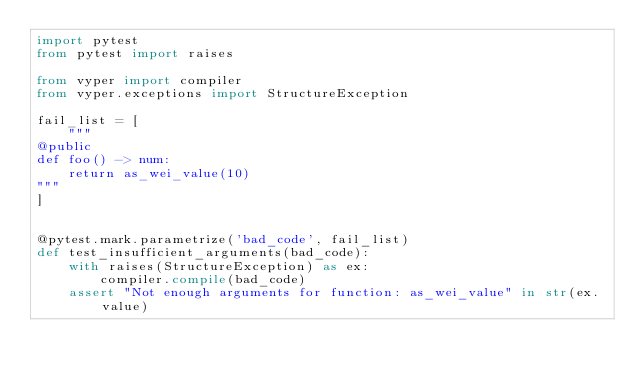Convert code to text. <code><loc_0><loc_0><loc_500><loc_500><_Python_>import pytest
from pytest import raises

from vyper import compiler
from vyper.exceptions import StructureException

fail_list = [
    """
@public
def foo() -> num:
    return as_wei_value(10)
"""
]


@pytest.mark.parametrize('bad_code', fail_list)
def test_insufficient_arguments(bad_code):
    with raises(StructureException) as ex:
        compiler.compile(bad_code)
    assert "Not enough arguments for function: as_wei_value" in str(ex.value)
</code> 